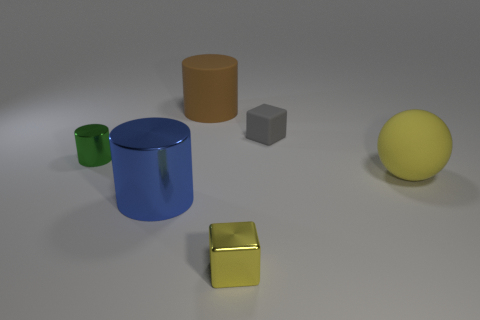Is the color of the small shiny object that is on the right side of the large brown rubber cylinder the same as the cube that is behind the yellow shiny thing?
Provide a succinct answer. No. What is the material of the other blue cylinder that is the same size as the rubber cylinder?
Ensure brevity in your answer.  Metal. Are there any green blocks that have the same size as the yellow shiny cube?
Keep it short and to the point. No. Is the number of small gray matte objects that are on the left side of the blue object less than the number of red shiny balls?
Give a very brief answer. No. Is the number of blue objects that are right of the small yellow object less than the number of tiny shiny cylinders that are behind the large blue thing?
Your response must be concise. Yes. What number of blocks are big cyan rubber things or blue objects?
Ensure brevity in your answer.  0. Are the tiny block that is behind the big yellow object and the object that is to the left of the blue metal cylinder made of the same material?
Offer a very short reply. No. There is a shiny object that is the same size as the green metallic cylinder; what shape is it?
Ensure brevity in your answer.  Cube. How many other things are there of the same color as the small cylinder?
Offer a terse response. 0. How many brown objects are either big rubber spheres or cylinders?
Keep it short and to the point. 1. 